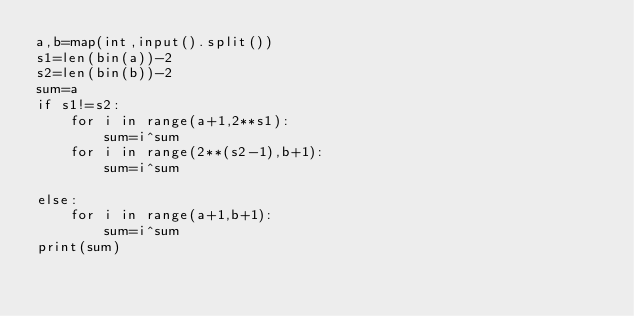<code> <loc_0><loc_0><loc_500><loc_500><_Python_>a,b=map(int,input().split())
s1=len(bin(a))-2
s2=len(bin(b))-2
sum=a
if s1!=s2:
    for i in range(a+1,2**s1):
        sum=i^sum
    for i in range(2**(s2-1),b+1):
        sum=i^sum
    
else:
    for i in range(a+1,b+1):
        sum=i^sum
print(sum)</code> 